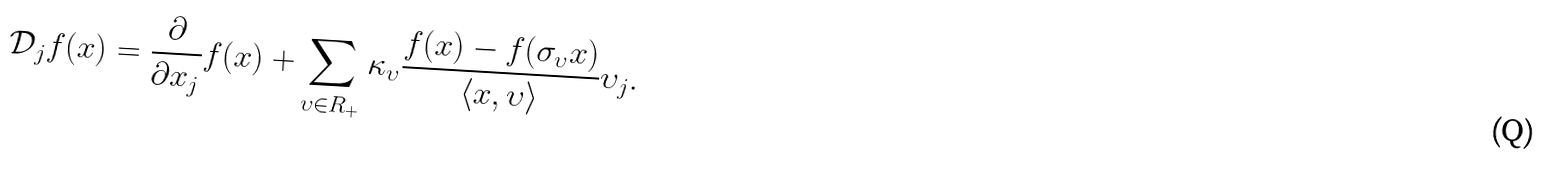<formula> <loc_0><loc_0><loc_500><loc_500>\mathcal { D } _ { j } f ( x ) = \frac { \partial } { \partial x _ { j } } f ( x ) + \sum _ { \upsilon \in R _ { + } } \kappa _ { \upsilon } \frac { f ( x ) - f ( \sigma _ { \upsilon } x ) } { \langle x , \upsilon \rangle } \upsilon _ { j } .</formula> 